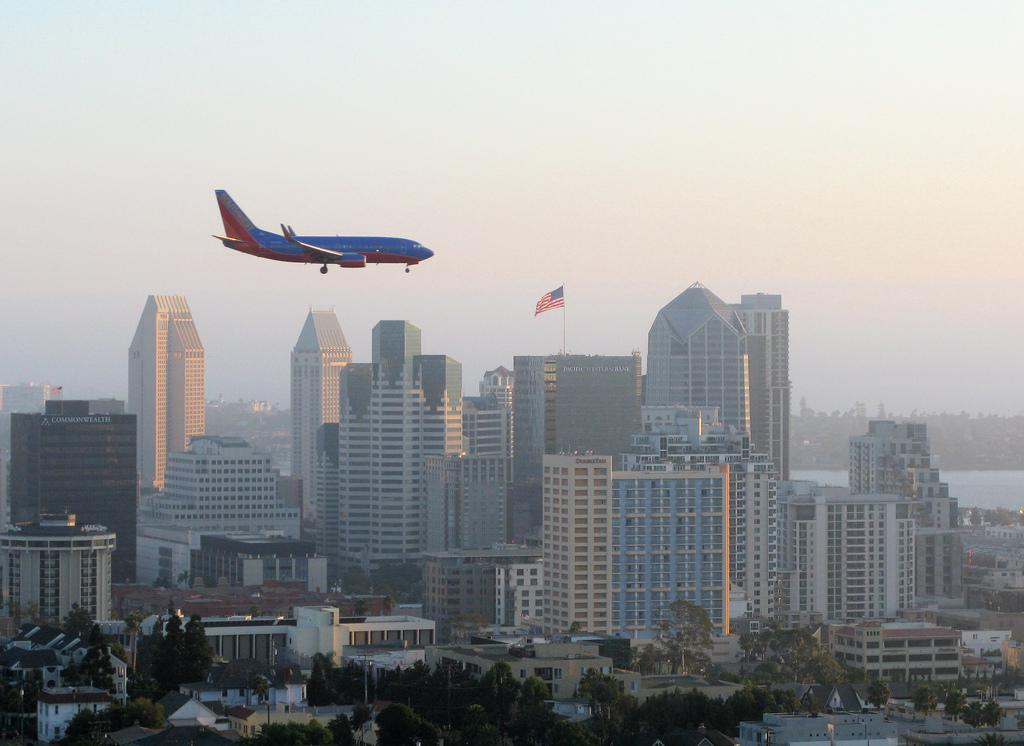Question: what kind of vehicle is that?
Choices:
A. A train.
B. A truck.
C. A bus.
D. An airplane.
Answer with the letter. Answer: D Question: how do you know it's a city?
Choices:
A. Lots of people.
B. Pollution.
C. Large buildings.
D. Noisy.
Answer with the letter. Answer: C Question: what country's flag is flying?
Choices:
A. Canada.
B. Mexico.
C. United states.
D. Germany.
Answer with the letter. Answer: C Question: where is the flag located?
Choices:
A. On top of a building.
B. Above the door.
C. On the pole.
D. Outside.
Answer with the letter. Answer: A Question: what type of flag is this?
Choices:
A. Utah state flag.
B. POW flag.
C. Confederate flag.
D. An american flag.
Answer with the letter. Answer: D Question: what color besides red is on the plane?
Choices:
A. White.
B. Orange.
C. Blue.
D. Black.
Answer with the letter. Answer: C Question: what is flying from the top of a building?
Choices:
A. A kite.
B. A confederate flag.
C. An american flag.
D. A bee.
Answer with the letter. Answer: C Question: where is the large body of water?
Choices:
A. Surrounding the buildings.
B. On the east coast.
C. South of Mexico.
D. Next to the beach.
Answer with the letter. Answer: A Question: where are the skyscrapers?
Choices:
A. Near the street.
B. The city.
C. Beside other buildings.
D. Near Fifth Avenus.
Answer with the letter. Answer: B Question: what is to the right?
Choices:
A. A tree.
B. A bench.
C. A body of water.
D. A woman.
Answer with the letter. Answer: C Question: what color is the plane?
Choices:
A. Grey.
B. Red.
C. Blue.
D. White.
Answer with the letter. Answer: C Question: what are the two colors on the plane?
Choices:
A. Yellow and Green.
B. Orange and Purple.
C. Red and blue.
D. White and Pink.
Answer with the letter. Answer: C Question: where was this picture taken?
Choices:
A. Inside.
B. On the lawn.
C. Outside.
D. Near the tree.
Answer with the letter. Answer: C Question: what color is the airplane flying above the city?
Choices:
A. White.
B. Orange.
C. It is red and blue.
D. Black.
Answer with the letter. Answer: C Question: what is shown heading to the right?
Choices:
A. A red and blue plane is shown.
B. The green car.
C. The orange bike.
D. The brown cart.
Answer with the letter. Answer: A Question: what sort of buildings does this city show a lot of?
Choices:
A. One story.
B. Skyscrapers.
C. Large brick and mortar buildings.
D. Wood shingled homes.
Answer with the letter. Answer: B Question: why do the buildings in the picture seem almost to touch the plane?
Choices:
A. An optical illusion.
B. The painter's perspective.
C. Some are much shorter than those in comparison.
D. Many of them are very tall.
Answer with the letter. Answer: D 